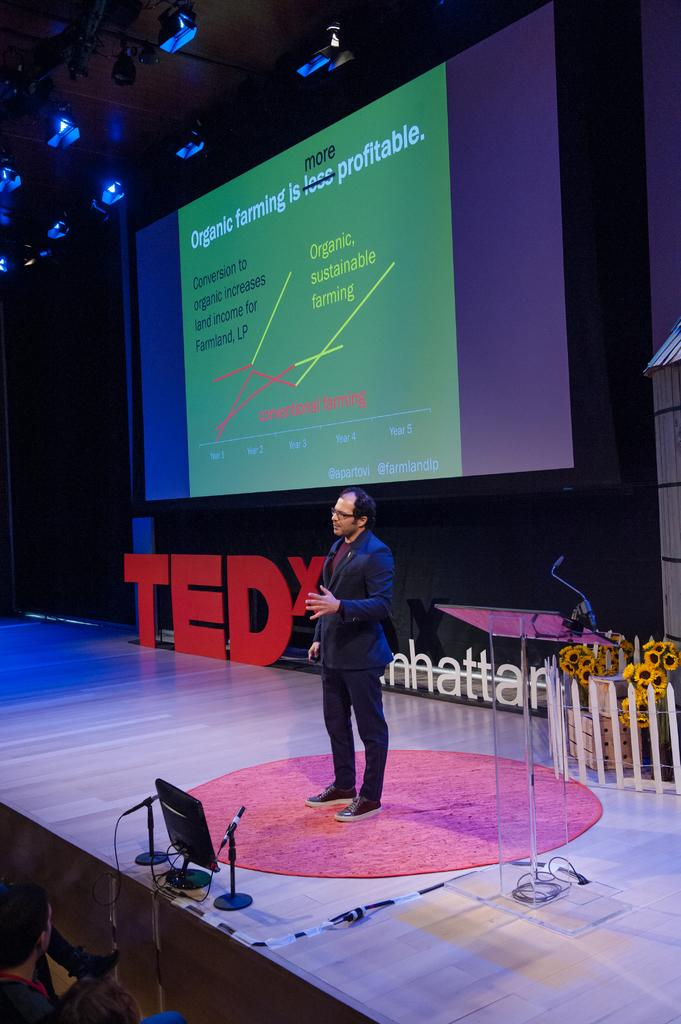What electronic device can be seen in the image? There is a laptop in the image. What is the man in the image sitting on? There is a mat in the image, and the man is sitting on it. What is the man wearing in the image? The man is wearing a black jacket. What is being displayed or projected in the image? There is a screen in the image, which suggests something is being displayed or projected. What type of illumination is visible in the image? There are lights visible in the image. What month is depicted in the image? There is no specific month depicted in the image; it does not contain any seasonal or calendar-related elements. Can you see any cobwebs in the image? There are no cobwebs present in the image. 